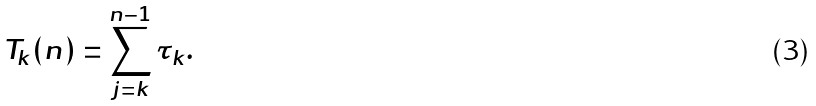<formula> <loc_0><loc_0><loc_500><loc_500>T _ { k } ( n ) = \sum _ { j = k } ^ { n - 1 } \tau _ { k } .</formula> 